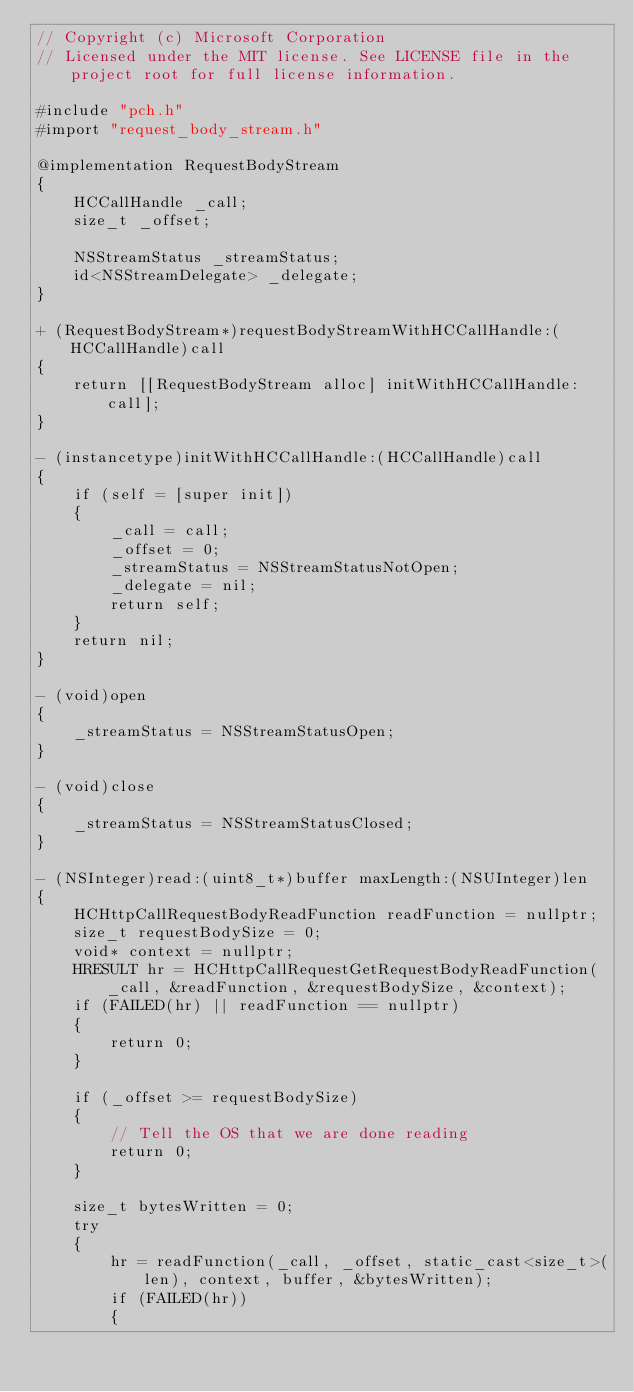Convert code to text. <code><loc_0><loc_0><loc_500><loc_500><_ObjectiveC_>// Copyright (c) Microsoft Corporation
// Licensed under the MIT license. See LICENSE file in the project root for full license information.

#include "pch.h"
#import "request_body_stream.h"

@implementation RequestBodyStream
{
    HCCallHandle _call;
    size_t _offset;

    NSStreamStatus _streamStatus;
    id<NSStreamDelegate> _delegate;
}

+ (RequestBodyStream*)requestBodyStreamWithHCCallHandle:(HCCallHandle)call
{
    return [[RequestBodyStream alloc] initWithHCCallHandle:call];
}

- (instancetype)initWithHCCallHandle:(HCCallHandle)call
{
    if (self = [super init])
    {
        _call = call;
        _offset = 0;
        _streamStatus = NSStreamStatusNotOpen;
        _delegate = nil;
        return self;
    }
    return nil;
}

- (void)open
{
    _streamStatus = NSStreamStatusOpen;
}

- (void)close
{
    _streamStatus = NSStreamStatusClosed;
}

- (NSInteger)read:(uint8_t*)buffer maxLength:(NSUInteger)len
{
    HCHttpCallRequestBodyReadFunction readFunction = nullptr;
    size_t requestBodySize = 0;
    void* context = nullptr;
    HRESULT hr = HCHttpCallRequestGetRequestBodyReadFunction(_call, &readFunction, &requestBodySize, &context);
    if (FAILED(hr) || readFunction == nullptr)
    {
        return 0;
    }

    if (_offset >= requestBodySize)
    {
        // Tell the OS that we are done reading
        return 0;
    }

    size_t bytesWritten = 0;
    try
    {
        hr = readFunction(_call, _offset, static_cast<size_t>(len), context, buffer, &bytesWritten);
        if (FAILED(hr))
        {</code> 